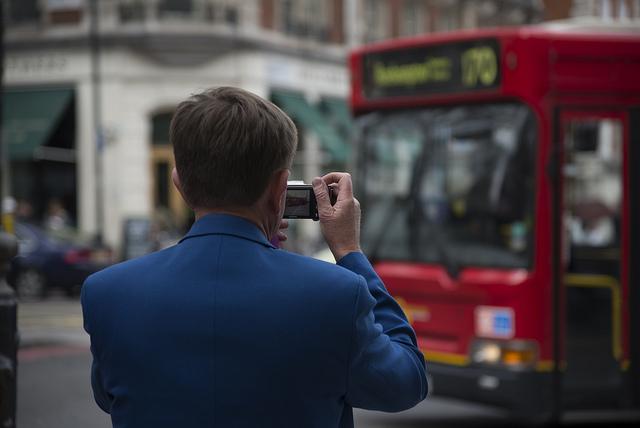Is the person blurry?
Short answer required. No. What color is the bus?
Write a very short answer. Red. Is this photo back and white?
Be succinct. No. What is on the man's face?
Answer briefly. Camera. What is the man doing in the foreground?
Give a very brief answer. Taking picture. Is there a double decker bus?
Be succinct. No. What is the man holding?
Concise answer only. Camera. What is the color of the jacket?
Answer briefly. Blue. 